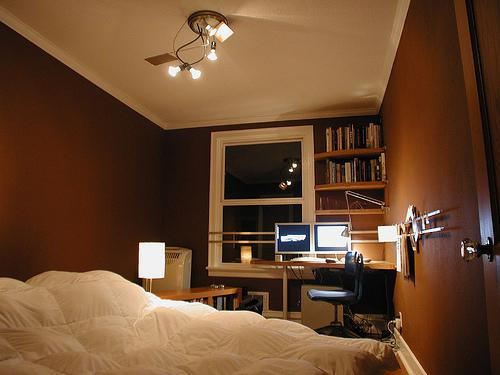Question: when was the picture taken?
Choices:
A. Dusk.
B. Dawn.
C. Noon.
D. At night.
Answer with the letter. Answer: D Question: what color are the walls?
Choices:
A. Pink.
B. Green.
C. Blue.
D. Brown.
Answer with the letter. Answer: D Question: how many light bulbs are there?
Choices:
A. Six.
B. Two.
C. Five.
D. Four.
Answer with the letter. Answer: D Question: what color is the ceiling?
Choices:
A. Beige.
B. Brown.
C. White.
D. Yellow.
Answer with the letter. Answer: C Question: where was the picture taken?
Choices:
A. At the clinic.
B. In a home office.
C. In a hospital.
D. In the convention center.
Answer with the letter. Answer: B 